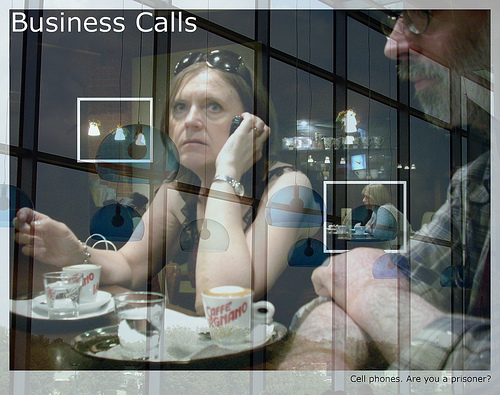Imagine a scenario where the woman is receiving life-changing news over the phone. How do you think her expression might change? If the woman received life-changing news, her expression might shift dramatically. She could show surprise, joy, or even distress, depending on the nature of the news. Her body language might also change significantly, perhaps leaning in closer to listen more intently or express disbelief. How do the reflections in the image contribute to its theme? The reflections in the image add depth and complexity, suggesting themes of contemplation and introspection. They might symbolize the dual nature of business and personal life or the interconnectedness of different aspects of one's life. If this image were a scene from a movie, what genre do you think it would belong to, and why? This image could belong to a drama or a thriller, given the serious and intense mood. The business setting and the focused expressions suggest a plot involving high stakes, professional conflicts, or important decisions. Create a backstory for the man in the image. The man, whose name is Robert, is a seasoned business consultant known for his strategic insights. He has been in the industry for over 20 years and has a reputation for turning around failing companies. Today, he's meeting his junior colleague, Lisa, to discuss a critical project for their biggest client. Despite his tough exterior, Robert is also known for mentoring young professionals and is highly respected in his field. Imagine there's a hidden secret in the image that could be discovered. What might it be? A hidden secret in the image could be a small, yet crucial, document discreetly tucked away under the coffee cup's saucer. This document might contain sensitive information about a major corporate acquisition that has been discreetly discussed among only a few individuals within the company. Describe a potential future event this business meeting could lead to. This business meeting could lead to a pivotal moment in both their careers. The discussions they have might lay the groundwork for a groundbreaking business deal that would significantly expand their company's market presence. This deal could attract international attention and install them as leading professionals in their industry. 